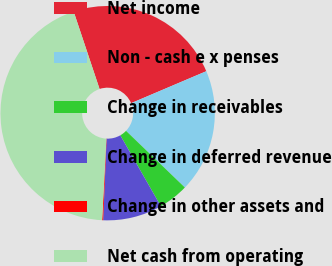Convert chart to OTSL. <chart><loc_0><loc_0><loc_500><loc_500><pie_chart><fcel>Net income<fcel>Non - cash e x penses<fcel>Change in receivables<fcel>Change in deferred revenue<fcel>Change in other assets and<fcel>Net cash from operating<nl><fcel>23.74%<fcel>18.6%<fcel>4.54%<fcel>8.93%<fcel>0.15%<fcel>44.05%<nl></chart> 